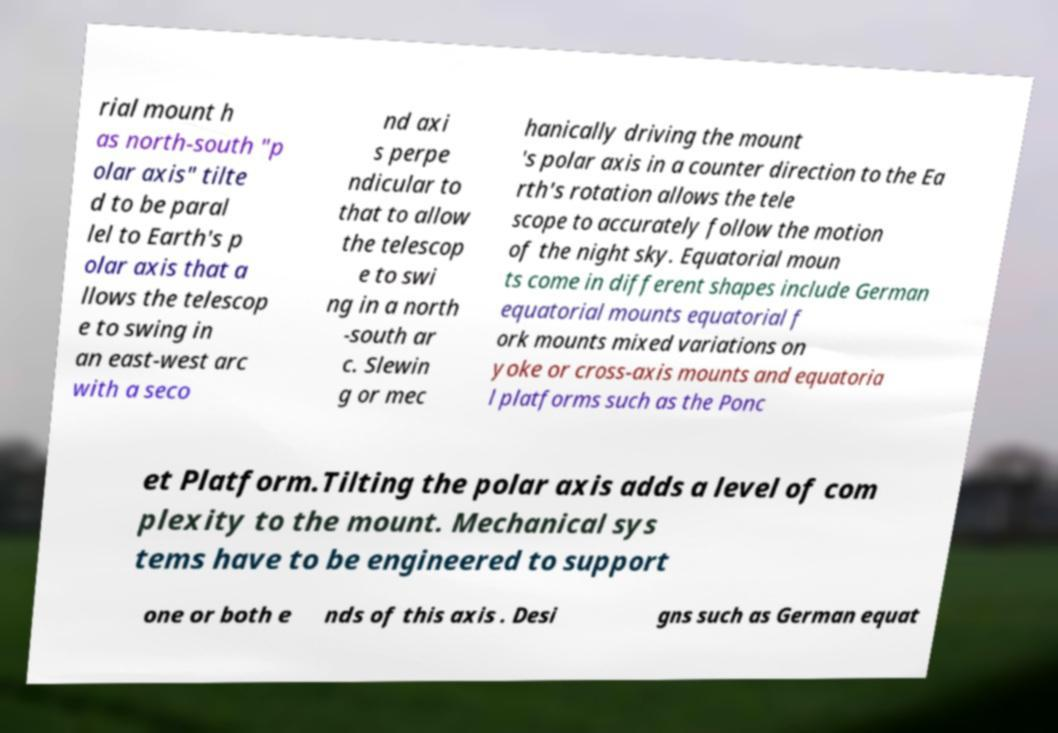Can you read and provide the text displayed in the image?This photo seems to have some interesting text. Can you extract and type it out for me? rial mount h as north-south "p olar axis" tilte d to be paral lel to Earth's p olar axis that a llows the telescop e to swing in an east-west arc with a seco nd axi s perpe ndicular to that to allow the telescop e to swi ng in a north -south ar c. Slewin g or mec hanically driving the mount 's polar axis in a counter direction to the Ea rth's rotation allows the tele scope to accurately follow the motion of the night sky. Equatorial moun ts come in different shapes include German equatorial mounts equatorial f ork mounts mixed variations on yoke or cross-axis mounts and equatoria l platforms such as the Ponc et Platform.Tilting the polar axis adds a level of com plexity to the mount. Mechanical sys tems have to be engineered to support one or both e nds of this axis . Desi gns such as German equat 